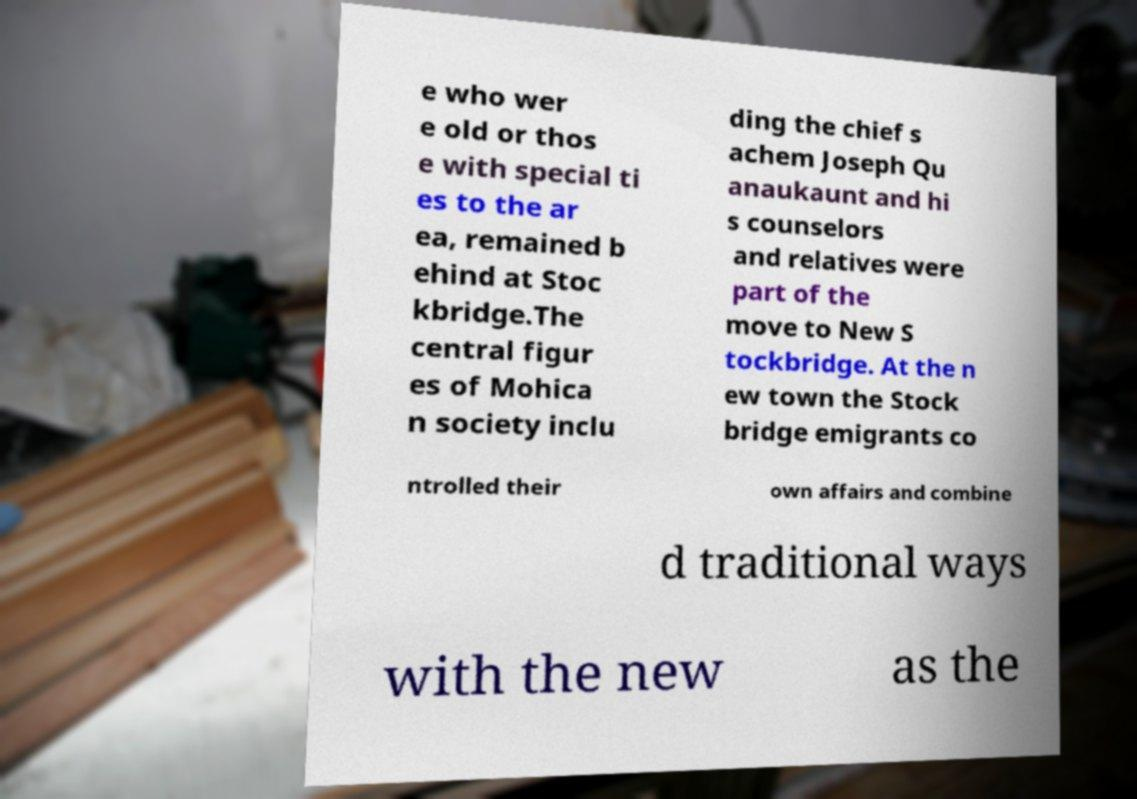Please identify and transcribe the text found in this image. e who wer e old or thos e with special ti es to the ar ea, remained b ehind at Stoc kbridge.The central figur es of Mohica n society inclu ding the chief s achem Joseph Qu anaukaunt and hi s counselors and relatives were part of the move to New S tockbridge. At the n ew town the Stock bridge emigrants co ntrolled their own affairs and combine d traditional ways with the new as the 